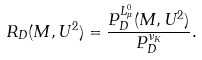<formula> <loc_0><loc_0><loc_500><loc_500>R _ { D } ( M , U ^ { 2 } ) = \frac { P _ { D } ^ { L _ { \mu } ^ { 0 } } ( M , U ^ { 2 } ) } { P _ { D } ^ { \nu _ { K } } } .</formula> 